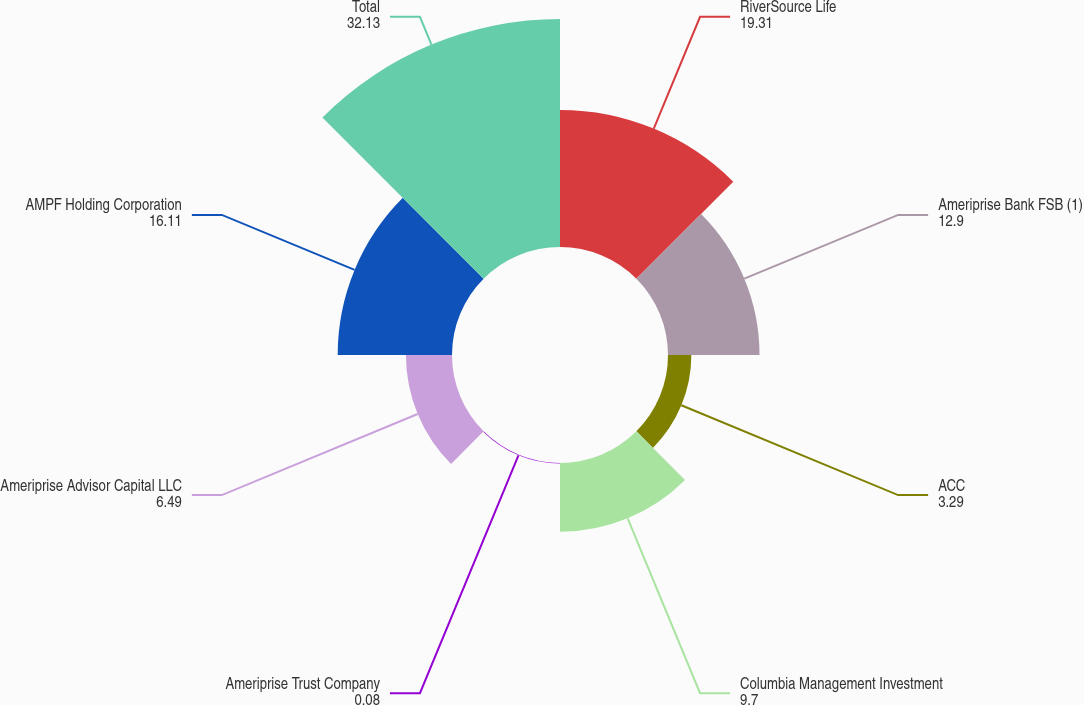<chart> <loc_0><loc_0><loc_500><loc_500><pie_chart><fcel>RiverSource Life<fcel>Ameriprise Bank FSB (1)<fcel>ACC<fcel>Columbia Management Investment<fcel>Ameriprise Trust Company<fcel>Ameriprise Advisor Capital LLC<fcel>AMPF Holding Corporation<fcel>Total<nl><fcel>19.31%<fcel>12.9%<fcel>3.29%<fcel>9.7%<fcel>0.08%<fcel>6.49%<fcel>16.11%<fcel>32.13%<nl></chart> 